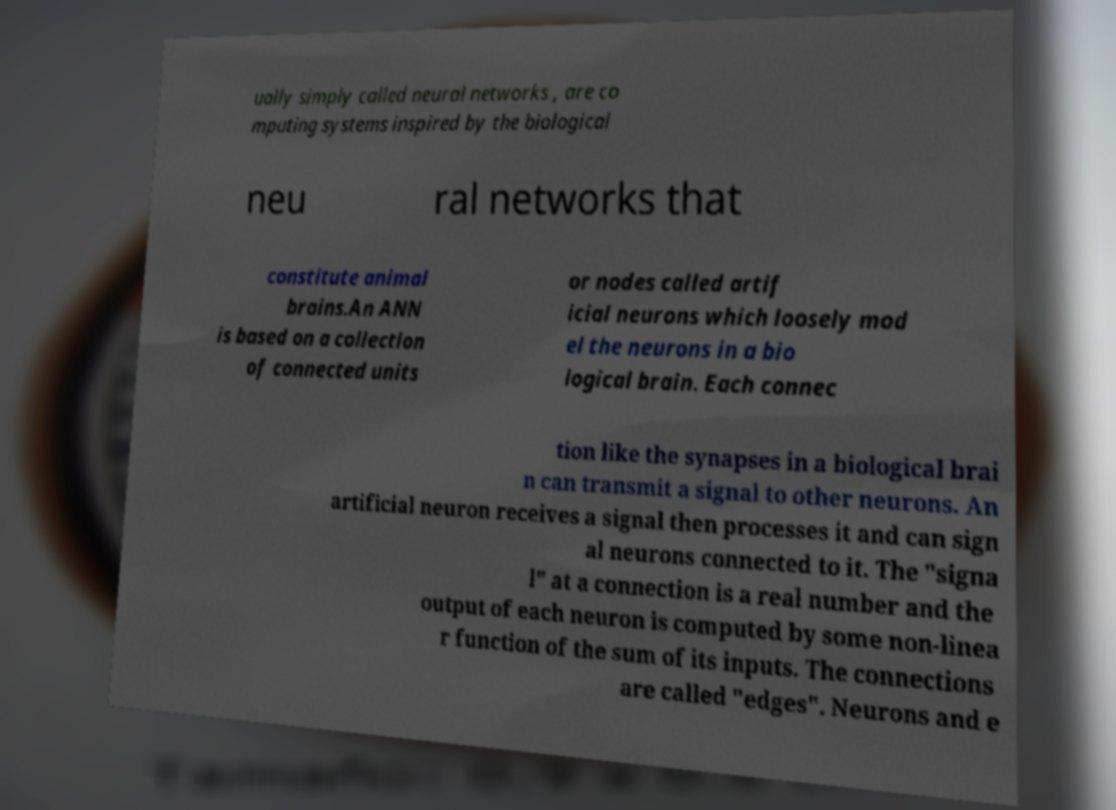I need the written content from this picture converted into text. Can you do that? ually simply called neural networks , are co mputing systems inspired by the biological neu ral networks that constitute animal brains.An ANN is based on a collection of connected units or nodes called artif icial neurons which loosely mod el the neurons in a bio logical brain. Each connec tion like the synapses in a biological brai n can transmit a signal to other neurons. An artificial neuron receives a signal then processes it and can sign al neurons connected to it. The "signa l" at a connection is a real number and the output of each neuron is computed by some non-linea r function of the sum of its inputs. The connections are called "edges". Neurons and e 